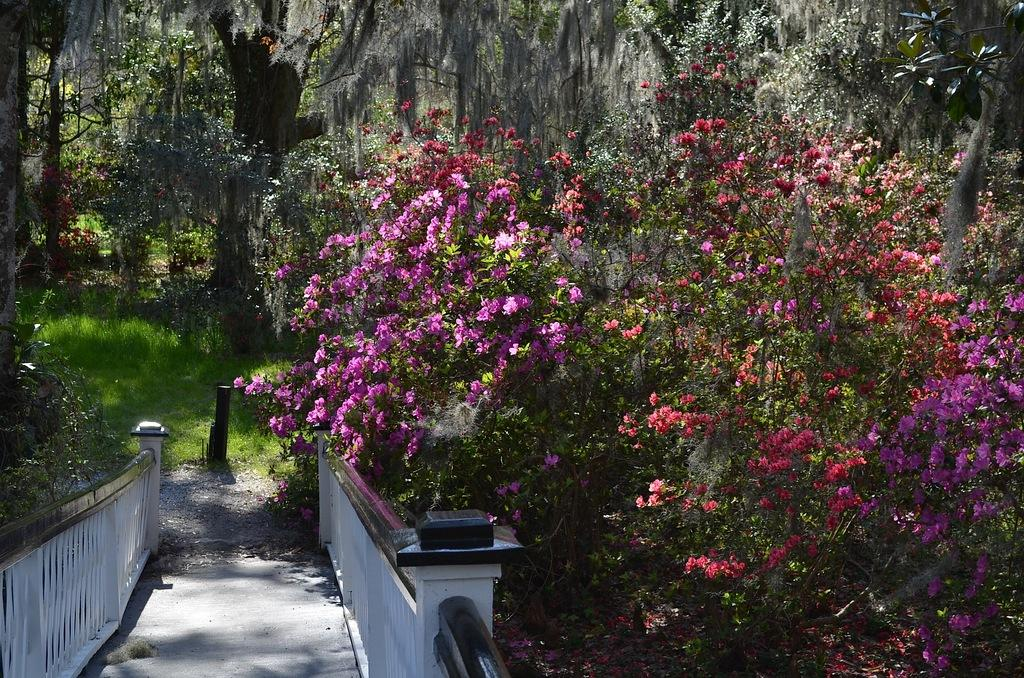What type of path can be seen in the image? There is a footpath in the image. What is located alongside the footpath? There is a fence in the image. What type of vegetation is present in the image? There is grass, trees, and flowers in the image. What colors are the flowers in the image? The flowers are pink and red in color. Can you describe the creature that is performing on the stage in the image? There is no creature or stage present in the image. 